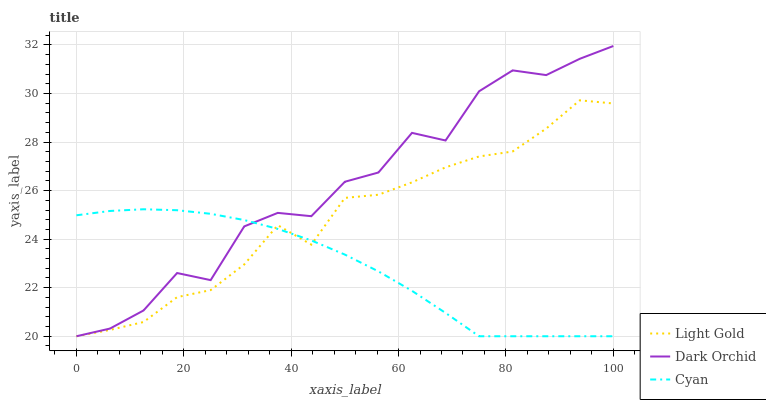Does Cyan have the minimum area under the curve?
Answer yes or no. Yes. Does Dark Orchid have the maximum area under the curve?
Answer yes or no. Yes. Does Light Gold have the minimum area under the curve?
Answer yes or no. No. Does Light Gold have the maximum area under the curve?
Answer yes or no. No. Is Cyan the smoothest?
Answer yes or no. Yes. Is Dark Orchid the roughest?
Answer yes or no. Yes. Is Light Gold the smoothest?
Answer yes or no. No. Is Light Gold the roughest?
Answer yes or no. No. Does Cyan have the lowest value?
Answer yes or no. Yes. Does Dark Orchid have the highest value?
Answer yes or no. Yes. Does Light Gold have the highest value?
Answer yes or no. No. Does Light Gold intersect Dark Orchid?
Answer yes or no. Yes. Is Light Gold less than Dark Orchid?
Answer yes or no. No. Is Light Gold greater than Dark Orchid?
Answer yes or no. No. 